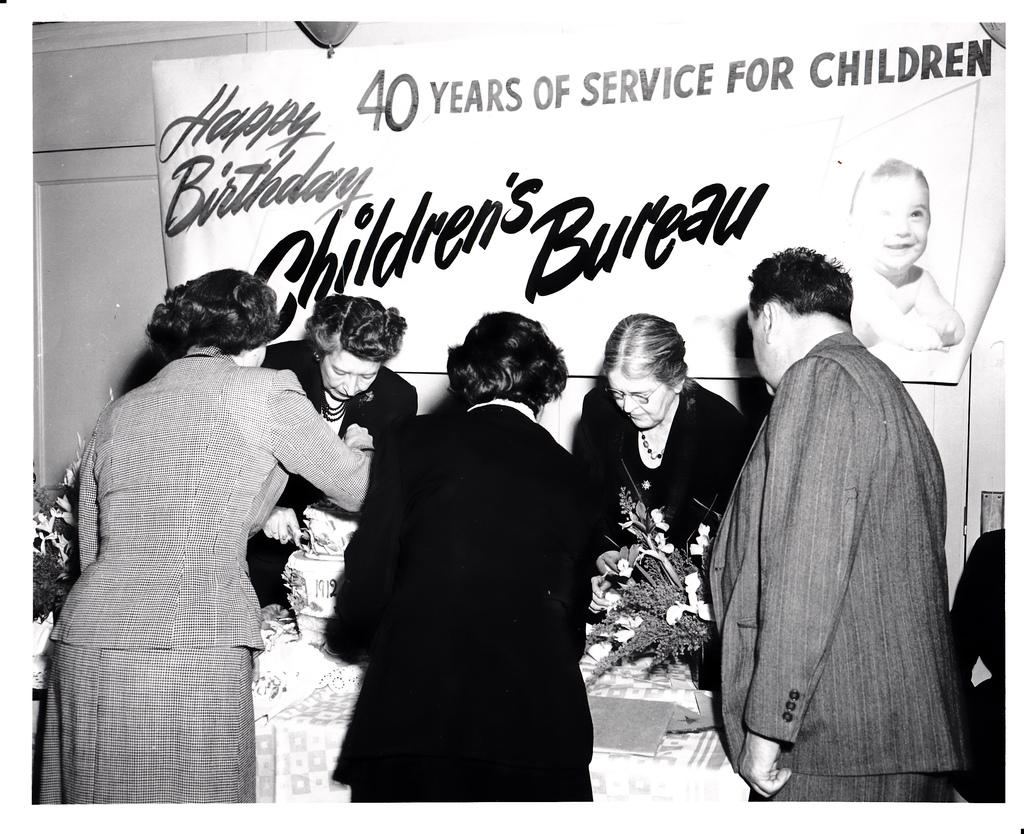What is the image is in color or black and white? The image is black and white. What can be seen in the image besides the table and cloth? There are persons and a flower vase on the table, as well as a banner in the background. What is the purpose of the cloth on the table? The cloth on the table might be for decoration or to protect the table surface. What is the color of the banner in the background? The color of the banner cannot be determined, as the image is black and white. What type of oatmeal is being served on the table in the image? There is no oatmeal present in the image; it features a table with a cloth, flower vase, and persons. What type of plants are growing on the persons in the image? There are no plants growing on the persons in the image. 